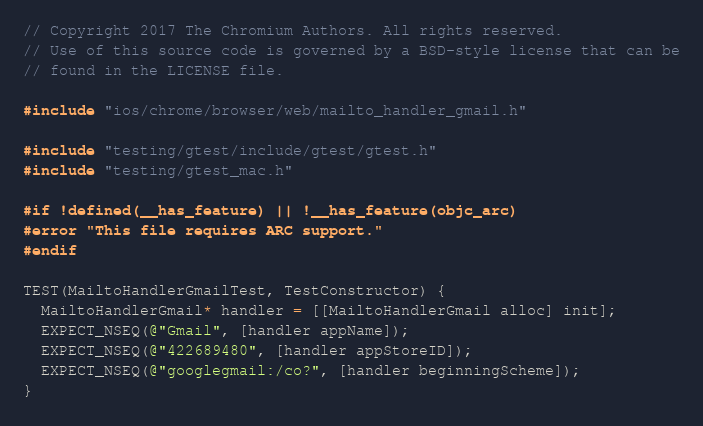<code> <loc_0><loc_0><loc_500><loc_500><_ObjectiveC_>// Copyright 2017 The Chromium Authors. All rights reserved.
// Use of this source code is governed by a BSD-style license that can be
// found in the LICENSE file.

#include "ios/chrome/browser/web/mailto_handler_gmail.h"

#include "testing/gtest/include/gtest/gtest.h"
#include "testing/gtest_mac.h"

#if !defined(__has_feature) || !__has_feature(objc_arc)
#error "This file requires ARC support."
#endif

TEST(MailtoHandlerGmailTest, TestConstructor) {
  MailtoHandlerGmail* handler = [[MailtoHandlerGmail alloc] init];
  EXPECT_NSEQ(@"Gmail", [handler appName]);
  EXPECT_NSEQ(@"422689480", [handler appStoreID]);
  EXPECT_NSEQ(@"googlegmail:/co?", [handler beginningScheme]);
}
</code> 